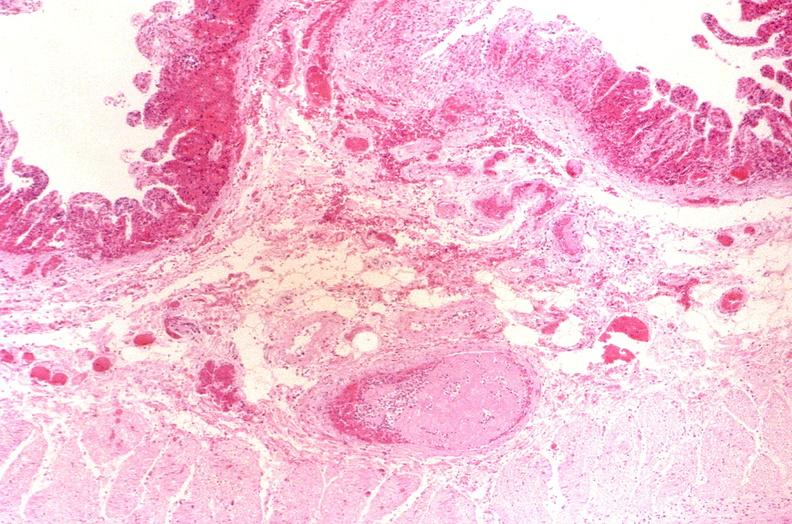does this image show thrombosed esophageal varices?
Answer the question using a single word or phrase. Yes 